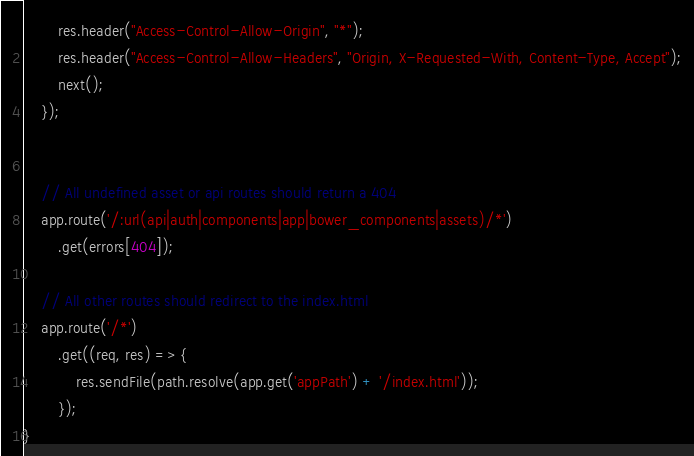<code> <loc_0><loc_0><loc_500><loc_500><_JavaScript_>        res.header("Access-Control-Allow-Origin", "*");
        res.header("Access-Control-Allow-Headers", "Origin, X-Requested-With, Content-Type, Accept");
        next();
    });


    // All undefined asset or api routes should return a 404
    app.route('/:url(api|auth|components|app|bower_components|assets)/*')
        .get(errors[404]);

    // All other routes should redirect to the index.html
    app.route('/*')
        .get((req, res) => {
            res.sendFile(path.resolve(app.get('appPath') + '/index.html'));
        });
}</code> 